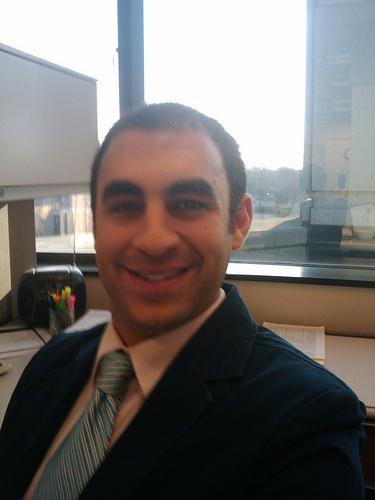How many people are pictured?
Give a very brief answer. 1. 